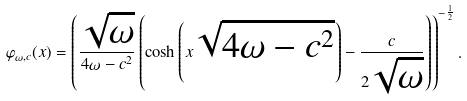Convert formula to latex. <formula><loc_0><loc_0><loc_500><loc_500>\varphi _ { \omega , c } ( x ) = \left ( \frac { \sqrt { \omega } } { 4 \omega - c ^ { 2 } } \left ( \cosh \left ( x \sqrt { 4 \omega - c ^ { 2 } } \right ) - \frac { c } { 2 \sqrt { \omega } } \right ) \right ) ^ { - \frac { 1 } { 2 } } .</formula> 